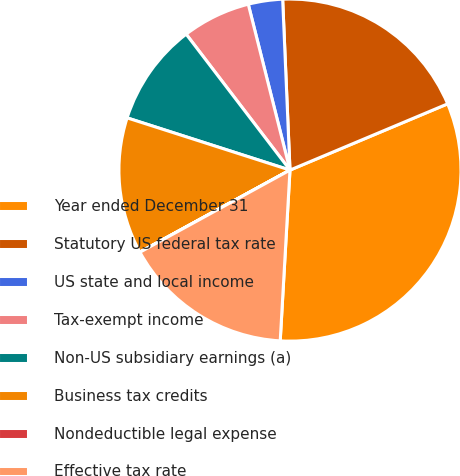<chart> <loc_0><loc_0><loc_500><loc_500><pie_chart><fcel>Year ended December 31<fcel>Statutory US federal tax rate<fcel>US state and local income<fcel>Tax-exempt income<fcel>Non-US subsidiary earnings (a)<fcel>Business tax credits<fcel>Nondeductible legal expense<fcel>Effective tax rate<nl><fcel>32.24%<fcel>19.35%<fcel>3.24%<fcel>6.46%<fcel>9.68%<fcel>12.9%<fcel>0.01%<fcel>16.12%<nl></chart> 